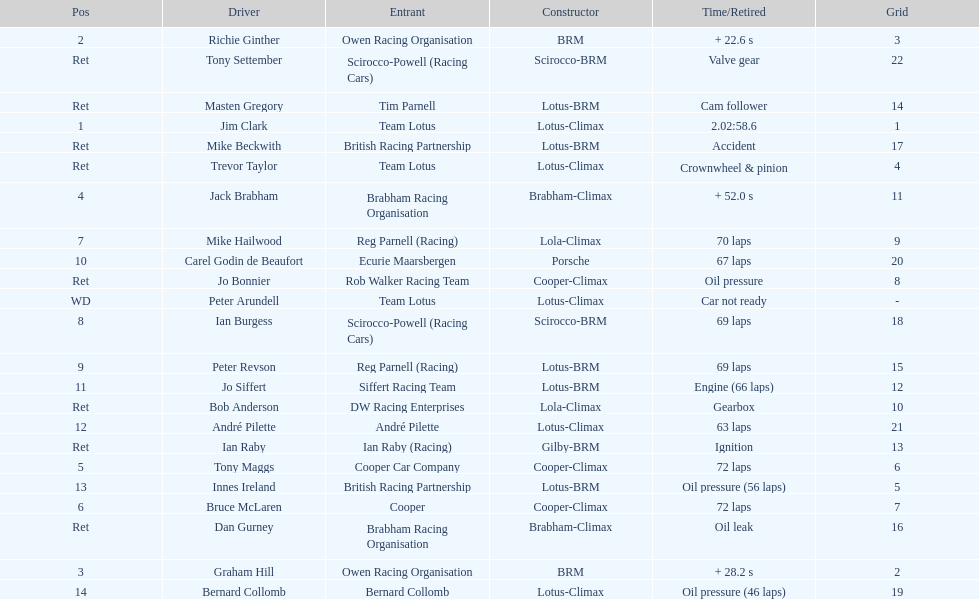Which driver did not have his/her car ready? Peter Arundell. 